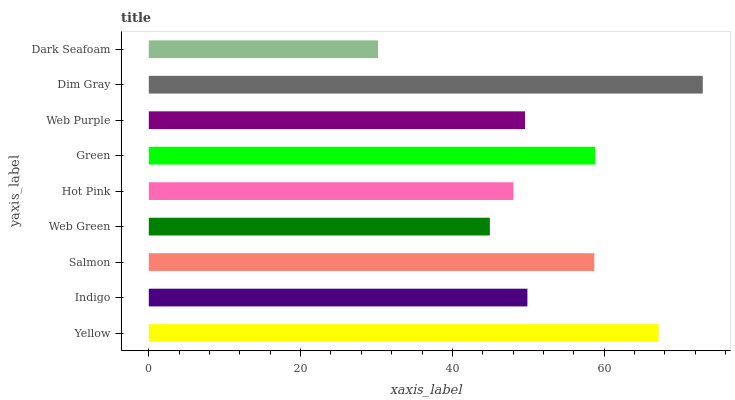Is Dark Seafoam the minimum?
Answer yes or no. Yes. Is Dim Gray the maximum?
Answer yes or no. Yes. Is Indigo the minimum?
Answer yes or no. No. Is Indigo the maximum?
Answer yes or no. No. Is Yellow greater than Indigo?
Answer yes or no. Yes. Is Indigo less than Yellow?
Answer yes or no. Yes. Is Indigo greater than Yellow?
Answer yes or no. No. Is Yellow less than Indigo?
Answer yes or no. No. Is Indigo the high median?
Answer yes or no. Yes. Is Indigo the low median?
Answer yes or no. Yes. Is Yellow the high median?
Answer yes or no. No. Is Hot Pink the low median?
Answer yes or no. No. 